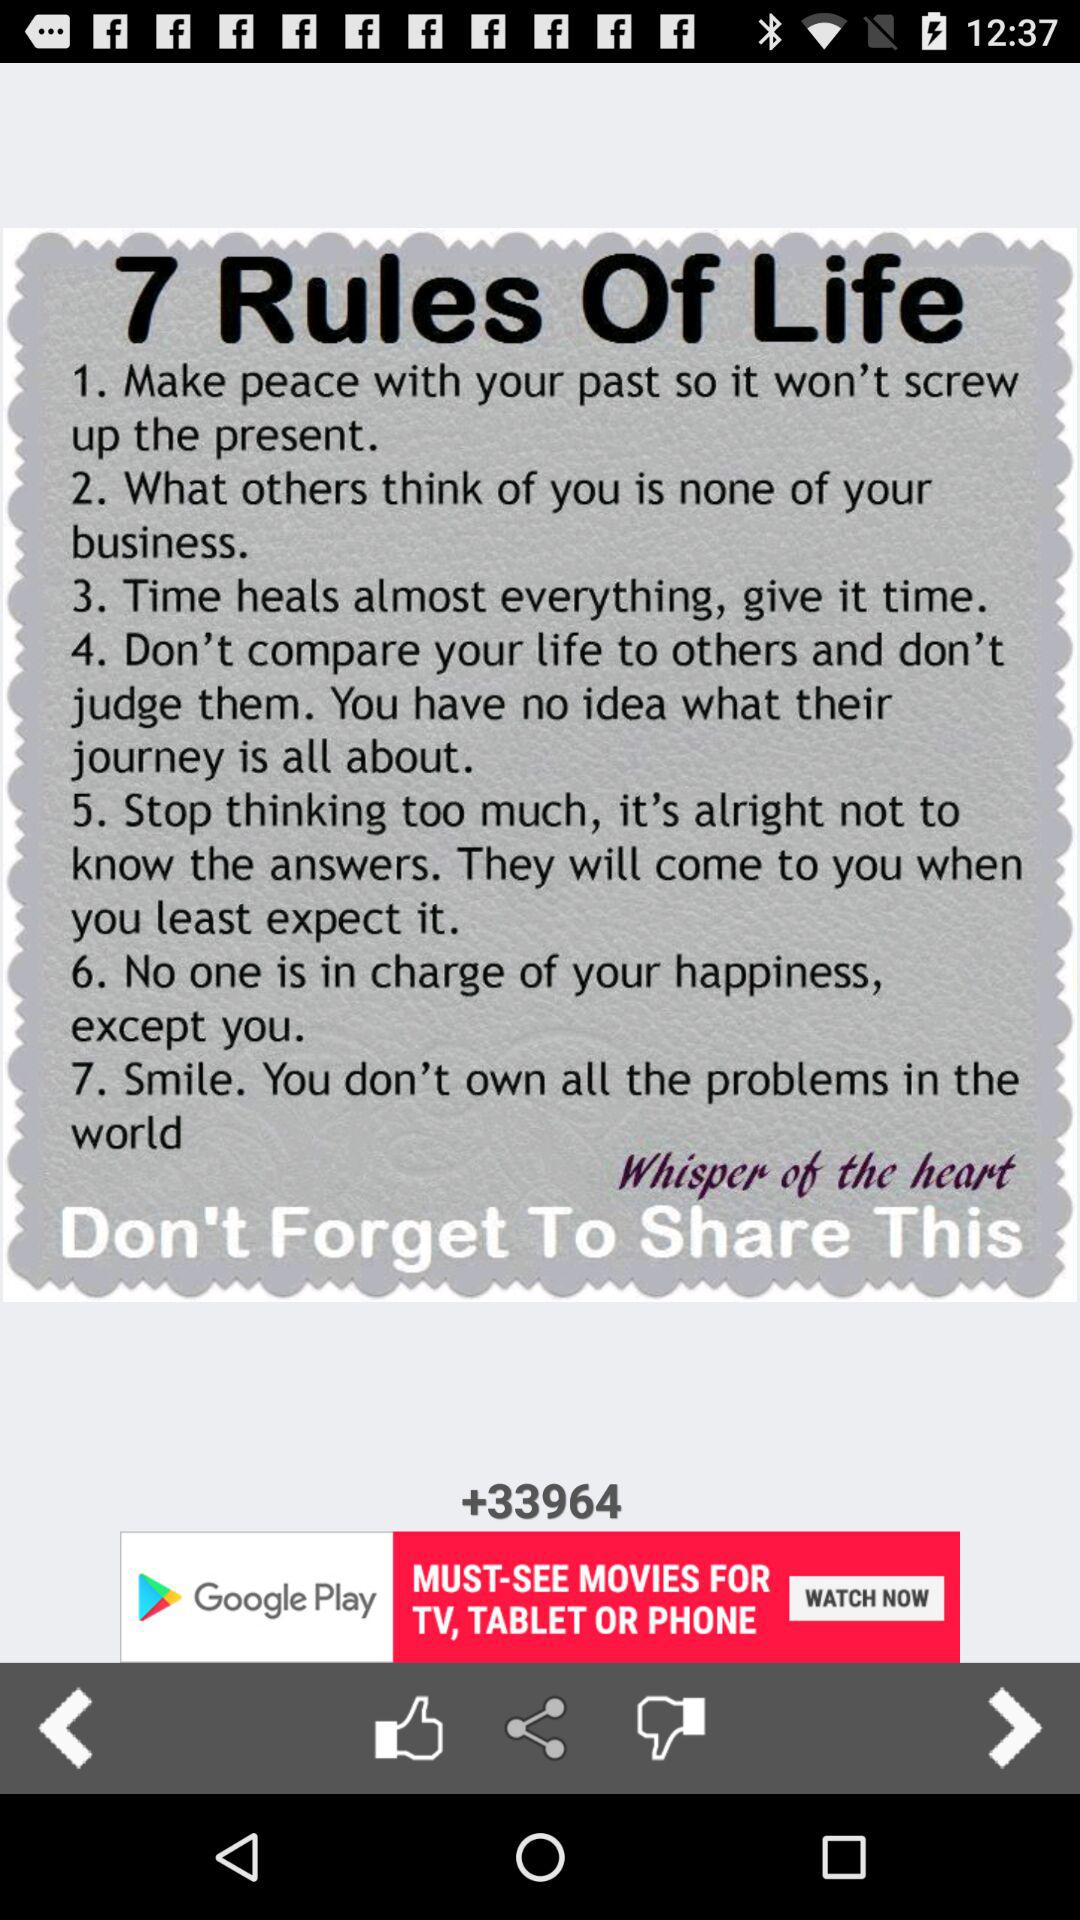How many rules of life are there?
Answer the question using a single word or phrase. 7 